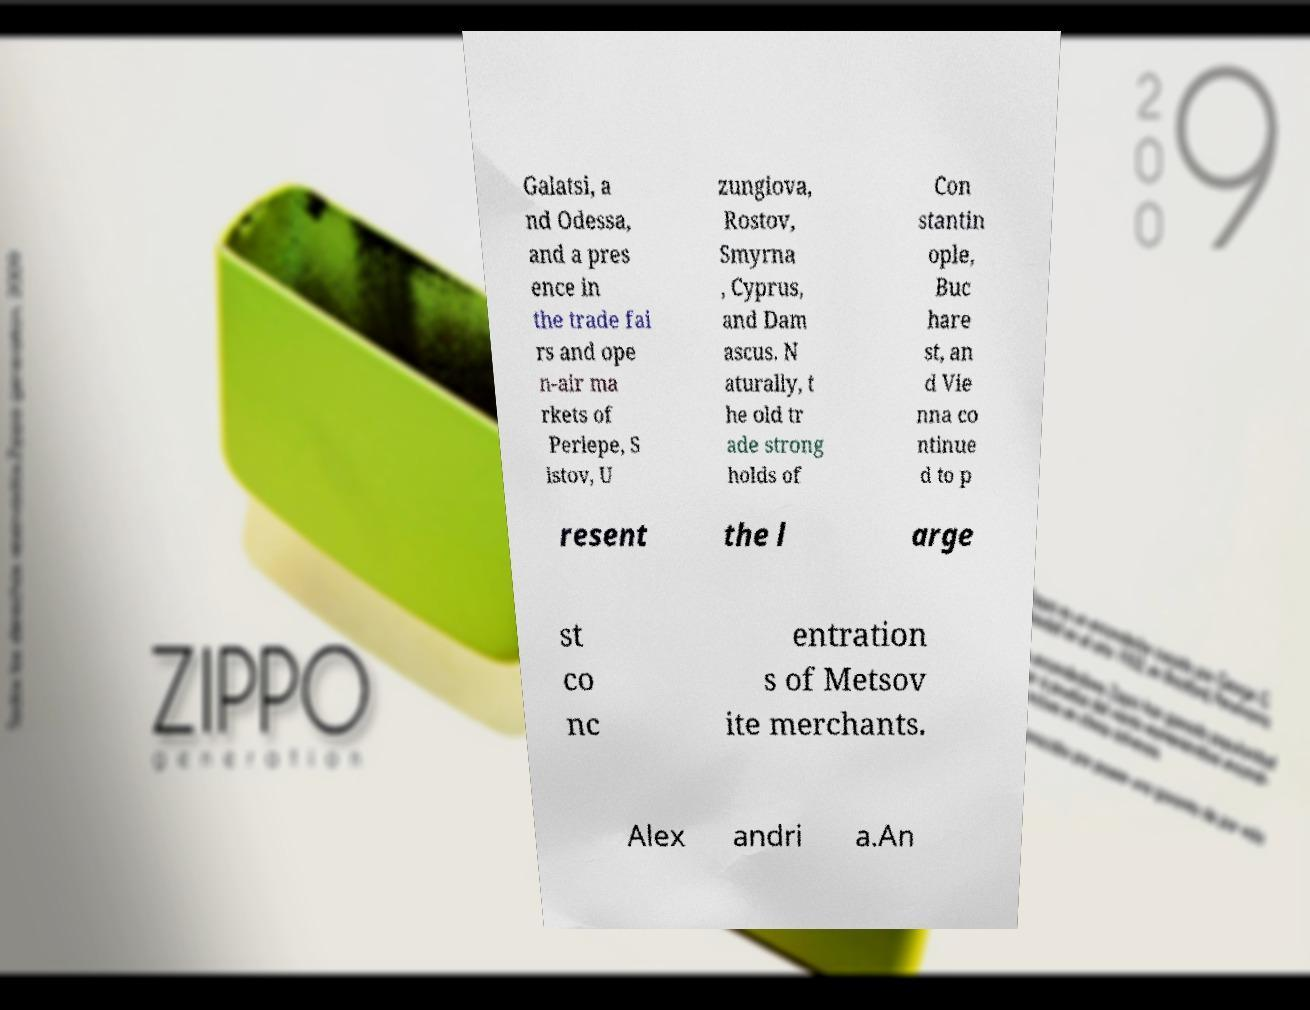What messages or text are displayed in this image? I need them in a readable, typed format. Galatsi, a nd Odessa, and a pres ence in the trade fai rs and ope n-air ma rkets of Perlepe, S istov, U zungiova, Rostov, Smyrna , Cyprus, and Dam ascus. N aturally, t he old tr ade strong holds of Con stantin ople, Buc hare st, an d Vie nna co ntinue d to p resent the l arge st co nc entration s of Metsov ite merchants. Alex andri a.An 